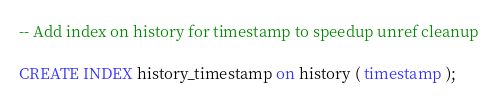<code> <loc_0><loc_0><loc_500><loc_500><_SQL_>-- Add index on history for timestamp to speedup unref cleanup

CREATE INDEX history_timestamp on history ( timestamp );
</code> 